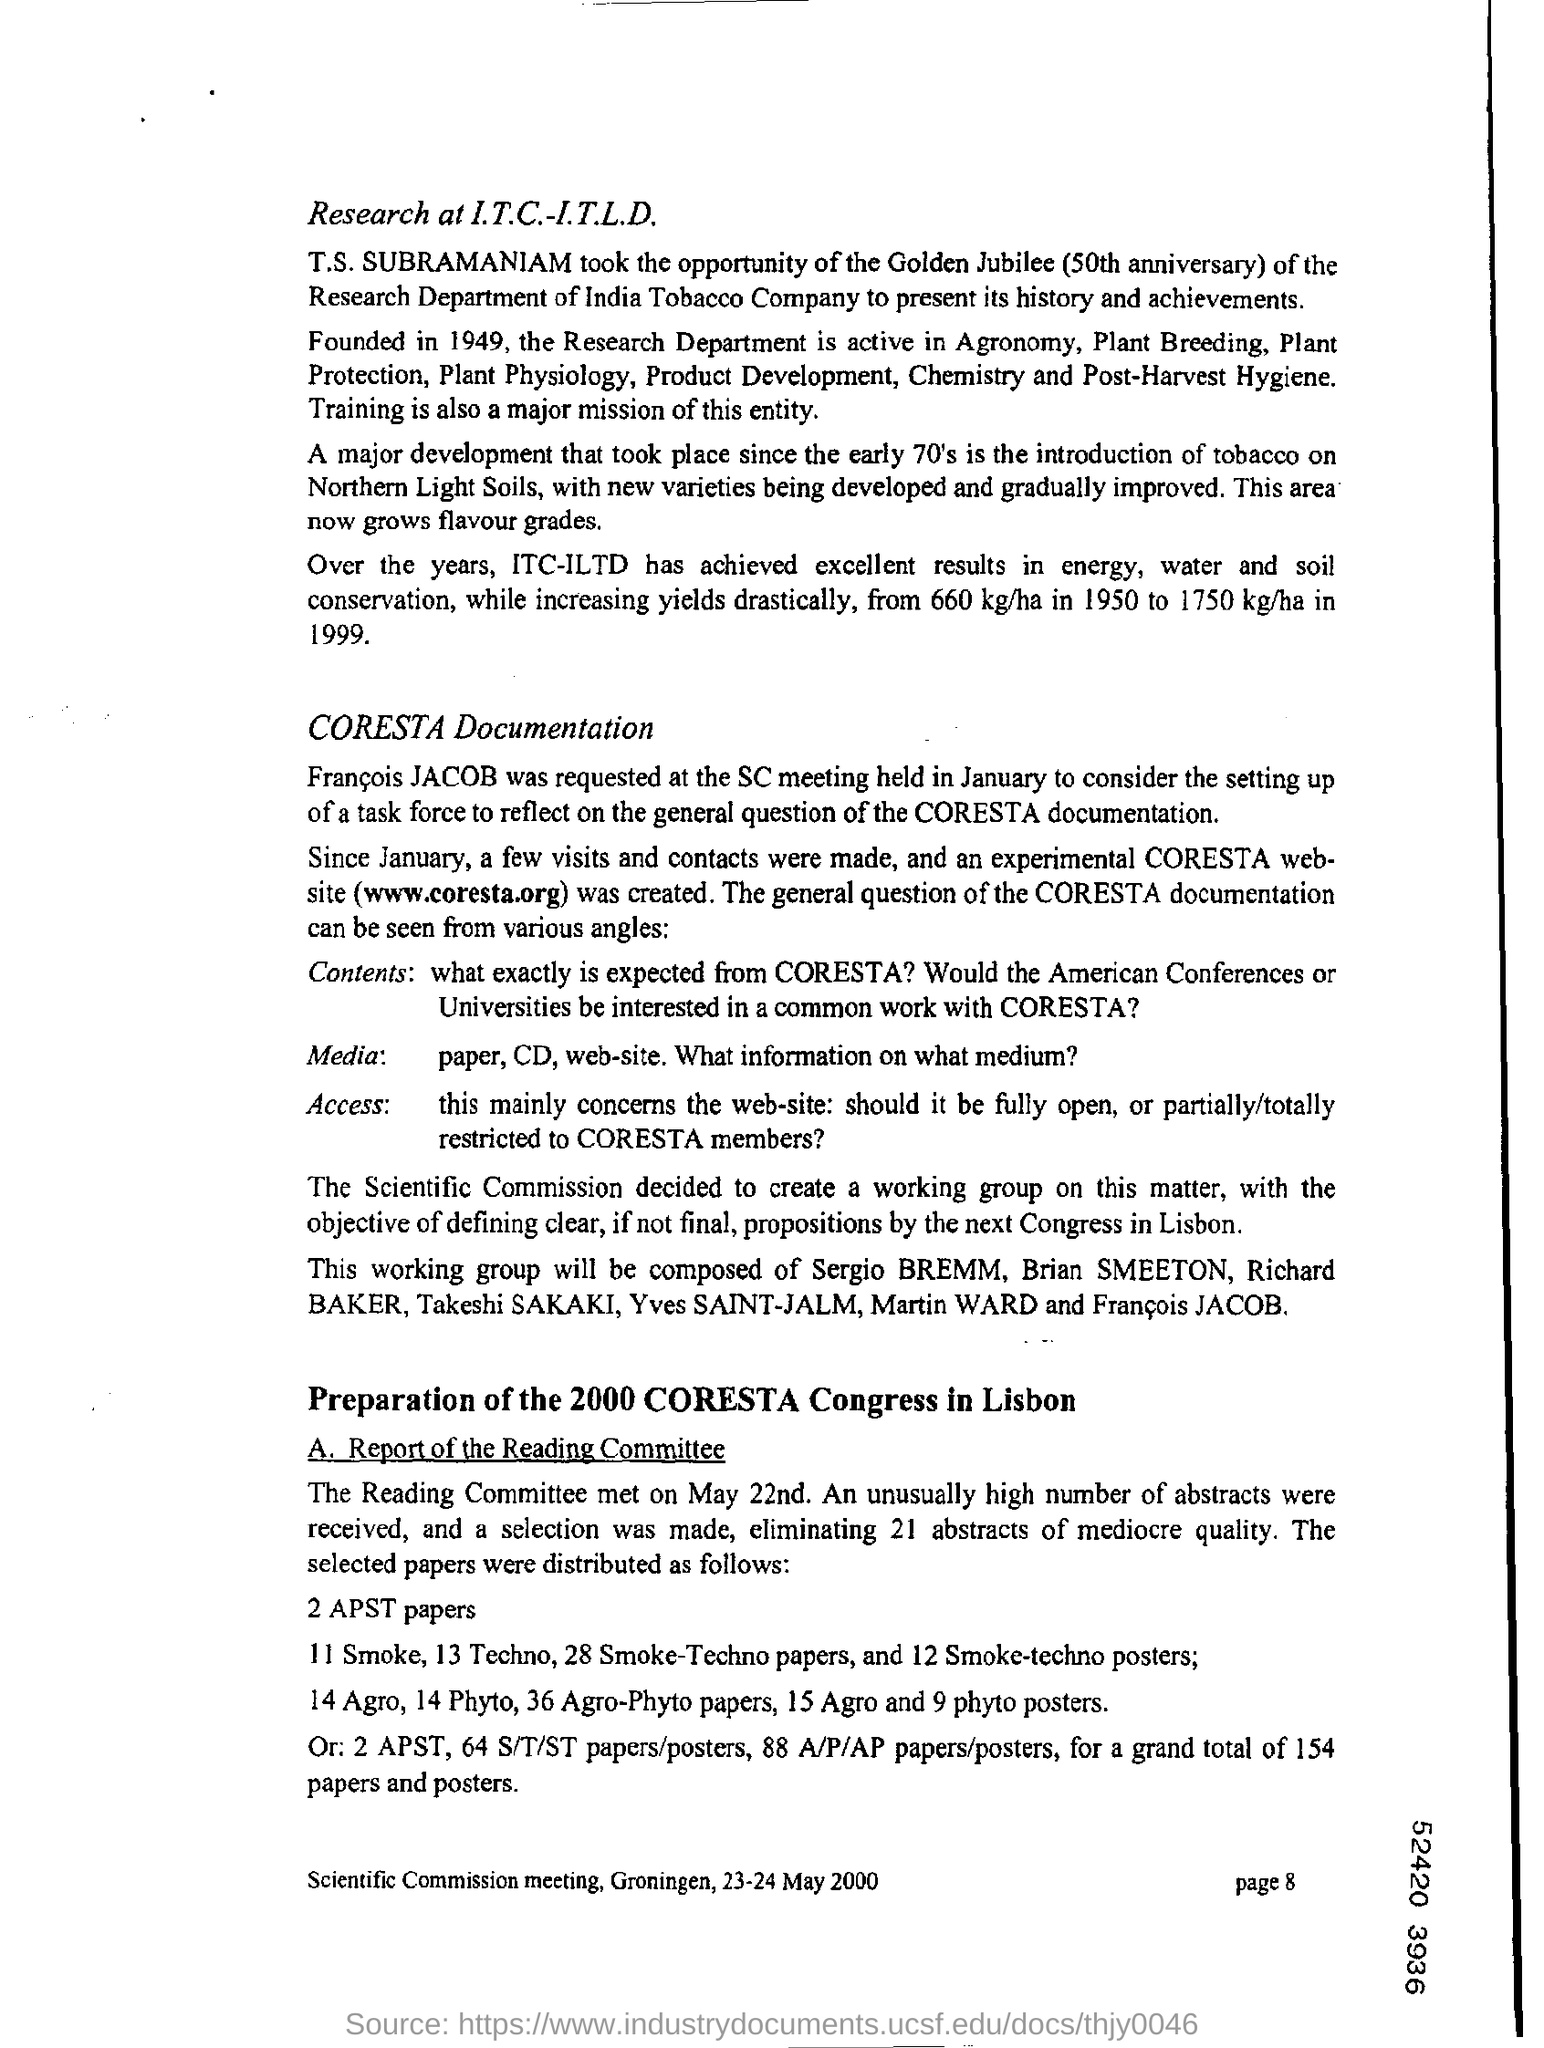Highlight a few significant elements in this photo. The research department was founded in 1949. 